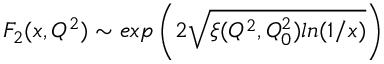Convert formula to latex. <formula><loc_0><loc_0><loc_500><loc_500>F _ { 2 } ( x , Q ^ { 2 } ) \sim e x p \left ( 2 \sqrt { \xi ( Q ^ { 2 } , Q _ { 0 } ^ { 2 } ) \ln ( 1 / x ) } \right )</formula> 